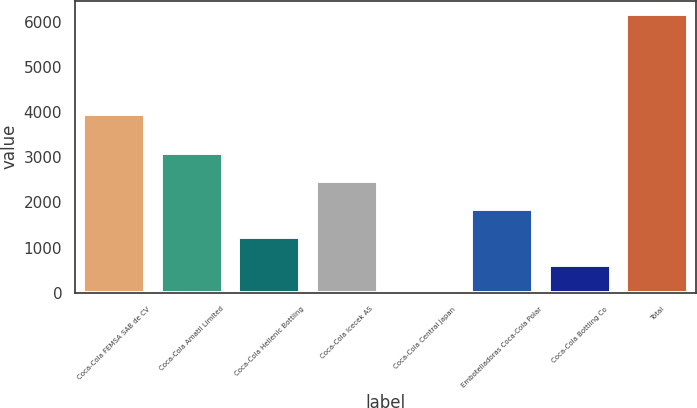Convert chart to OTSL. <chart><loc_0><loc_0><loc_500><loc_500><bar_chart><fcel>Coca-Cola FEMSA SAB de CV<fcel>Coca-Cola Amatil Limited<fcel>Coca-Cola Hellenic Bottling<fcel>Coca-Cola Icecek AS<fcel>Coca-Cola Central Japan<fcel>Embotelladoras Coca-Cola Polar<fcel>Coca-Cola Bottling Co<fcel>Total<nl><fcel>3963<fcel>3087.5<fcel>1236.8<fcel>2470.6<fcel>3<fcel>1853.7<fcel>619.9<fcel>6172<nl></chart> 